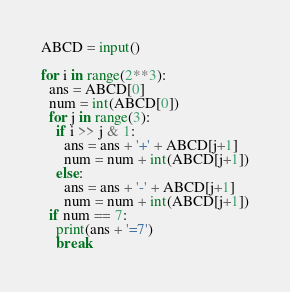Convert code to text. <code><loc_0><loc_0><loc_500><loc_500><_Python_>ABCD = input()

for i in range(2**3):
  ans = ABCD[0]
  num = int(ABCD[0])
  for j in range(3):
    if i >> j & 1:
      ans = ans + '+' + ABCD[j+1]
      num = num + int(ABCD[j+1])
    else:
      ans = ans + '-' + ABCD[j+1]
      num = num + int(ABCD[j+1])
  if num == 7:
    print(ans + '=7')
    break


</code> 